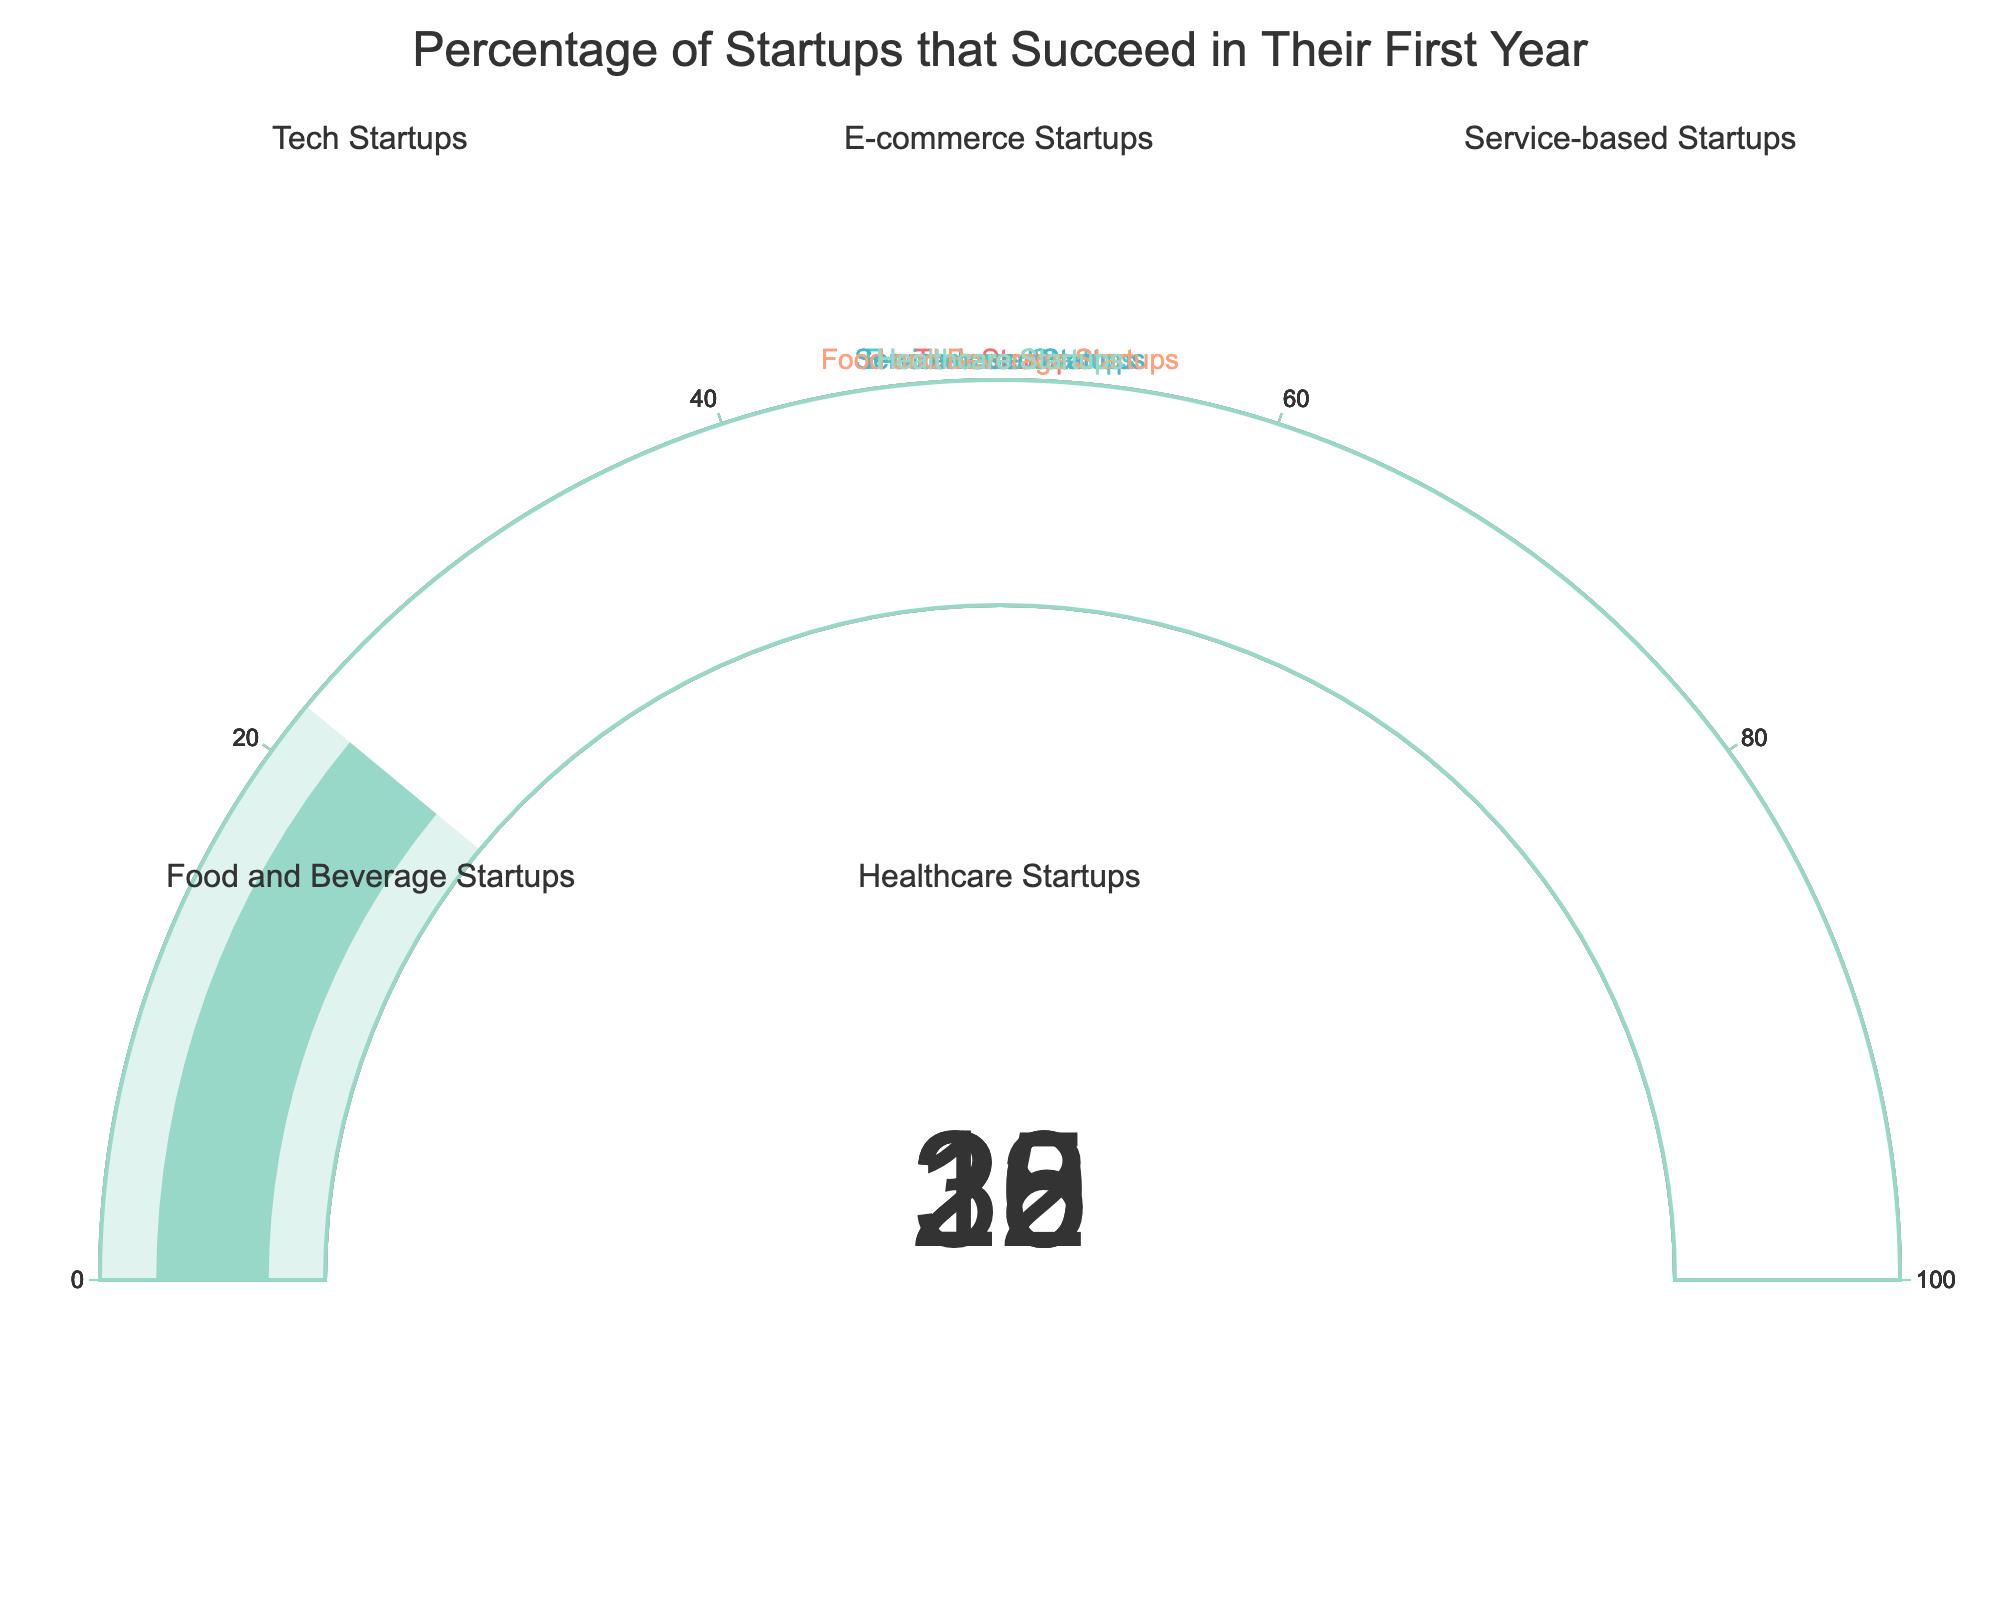What is the percentage of tech startups that succeed in their first year? The gauge for Tech Startups shows a value of 20%.
Answer: 20% Which category has the highest success rate? The gauge for Service-based Startups shows the highest value at 30%.
Answer: Service-based Startups How much higher is the success rate of E-commerce Startups compared to Food and Beverage Startups? The gauge for E-commerce Startups shows 25%, and the gauge for Food and Beverage Startups shows 18%. The difference is 25% - 18% = 7%.
Answer: 7% What's the average success rate of all the categories? Add the percentages shown in gauges: (20% + 25% + 30% + 18% + 22%) = 115%, then divide by 5 categories: 115% / 5 = 23%.
Answer: 23% Which category has a lower success rate, Healthcare Startups or Food and Beverage Startups? The success rate for Healthcare Startups is 22% and for Food and Beverage Startups is 18%, making Food and Beverage Startups' rate lower.
Answer: Food and Beverage Startups What is the combined success rate of Tech Startups and Healthcare Startups? Sum the percentages for Tech Startups (20%) and Healthcare Startups (22%): 20% + 22% = 42%.
Answer: 42% Which startup category falls between Tech Startups and E-commerce Startups in terms of success rate? The gauge for Tech Startups is 20% and for E-commerce Startups is 25%. Healthcare Startups with 22% falls between these values.
Answer: Healthcare Startups If you were to rank the categories from highest to lowest success rate, what would the order be? Service-based Startups: 30%, E-commerce Startups: 25%, Healthcare Startups: 22%, Tech Startups: 20%, Food and Beverage Startups: 18%.
Answer: Service-based, E-commerce, Healthcare, Tech, Food and Beverage Is any startup category below 20% in success rate? The gauge for Food and Beverage Startups shows a value of 18%, which is below 20%.
Answer: Yes Which categories are above the average success rate? The calculated average success rate is 23%. E-commerce Startups (25%), Service-based Startups (30%), and Healthcare Startups (22%) are above this average.
Answer: E-commerce, Service-based 